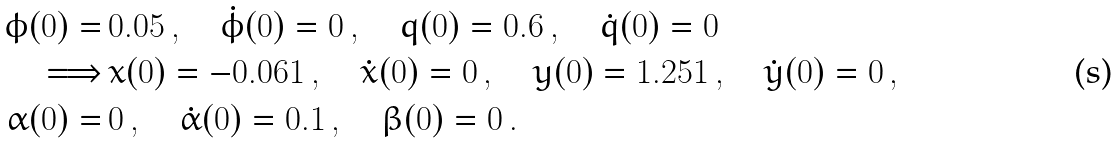Convert formula to latex. <formula><loc_0><loc_0><loc_500><loc_500>\phi ( 0 ) = & \, 0 . 0 5 \, , \quad \dot { \phi } ( 0 ) = 0 \, , \quad q ( 0 ) = 0 . 6 \, , \quad \dot { q } ( 0 ) = 0 \\ \Longrightarrow & \, x ( 0 ) = - 0 . 0 6 1 \, , \quad \dot { x } ( 0 ) = 0 \, , \quad y ( 0 ) = 1 . 2 5 1 \, , \quad \dot { y } ( 0 ) = 0 \, , \\ \quad \alpha ( 0 ) = & \, 0 \, , \quad \dot { \alpha } ( 0 ) = 0 . 1 \, , \quad \beta ( 0 ) = 0 \, .</formula> 